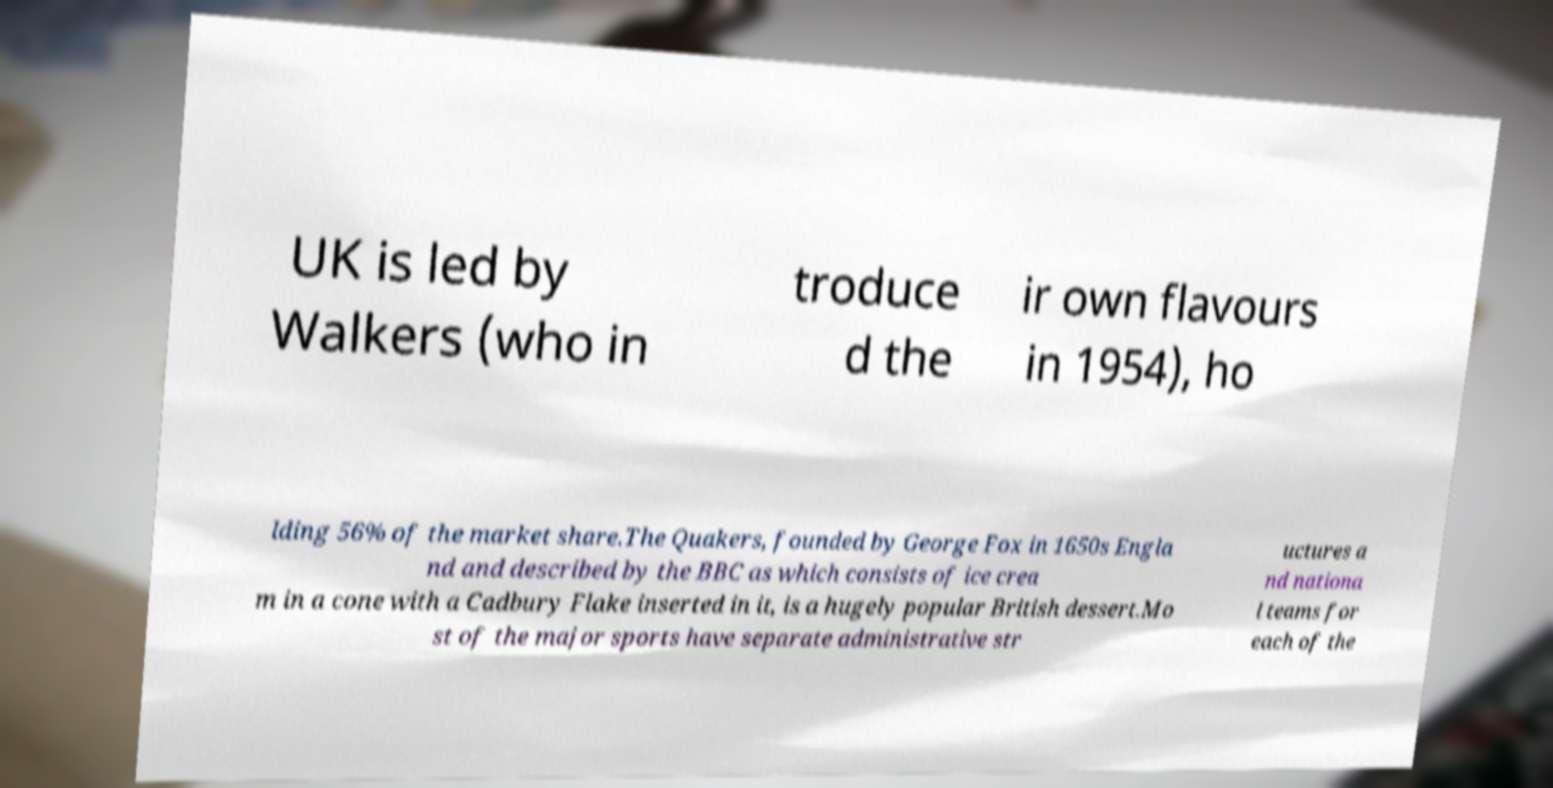Can you read and provide the text displayed in the image?This photo seems to have some interesting text. Can you extract and type it out for me? UK is led by Walkers (who in troduce d the ir own flavours in 1954), ho lding 56% of the market share.The Quakers, founded by George Fox in 1650s Engla nd and described by the BBC as which consists of ice crea m in a cone with a Cadbury Flake inserted in it, is a hugely popular British dessert.Mo st of the major sports have separate administrative str uctures a nd nationa l teams for each of the 